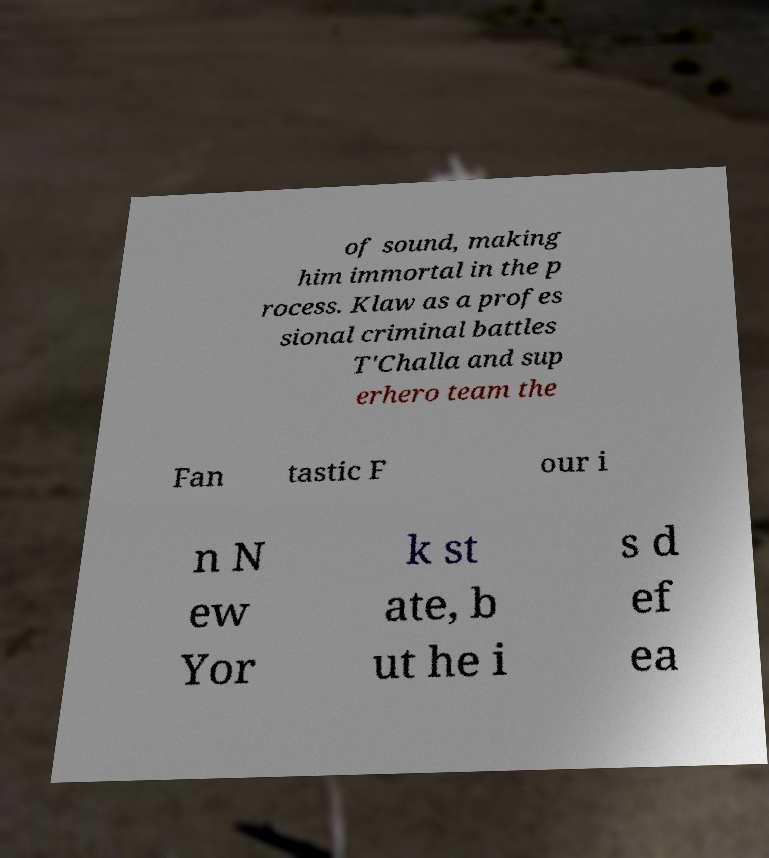Can you accurately transcribe the text from the provided image for me? of sound, making him immortal in the p rocess. Klaw as a profes sional criminal battles T'Challa and sup erhero team the Fan tastic F our i n N ew Yor k st ate, b ut he i s d ef ea 